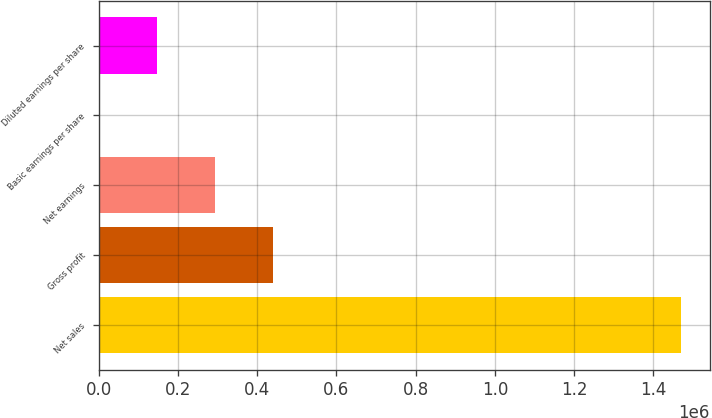Convert chart. <chart><loc_0><loc_0><loc_500><loc_500><bar_chart><fcel>Net sales<fcel>Gross profit<fcel>Net earnings<fcel>Basic earnings per share<fcel>Diluted earnings per share<nl><fcel>1.46979e+06<fcel>440939<fcel>293959<fcel>1.06<fcel>146980<nl></chart> 